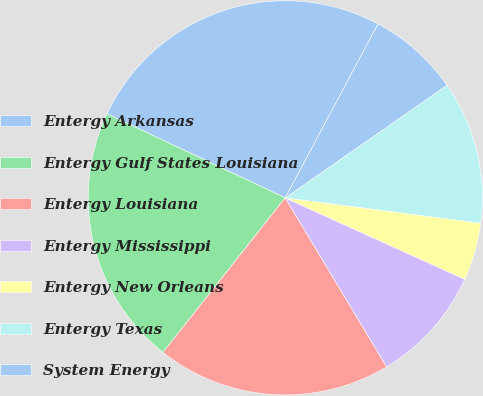Convert chart. <chart><loc_0><loc_0><loc_500><loc_500><pie_chart><fcel>Entergy Arkansas<fcel>Entergy Gulf States Louisiana<fcel>Entergy Louisiana<fcel>Entergy Mississippi<fcel>Entergy New Orleans<fcel>Entergy Texas<fcel>System Energy<nl><fcel>25.79%<fcel>21.36%<fcel>19.25%<fcel>9.62%<fcel>4.73%<fcel>11.73%<fcel>7.52%<nl></chart> 